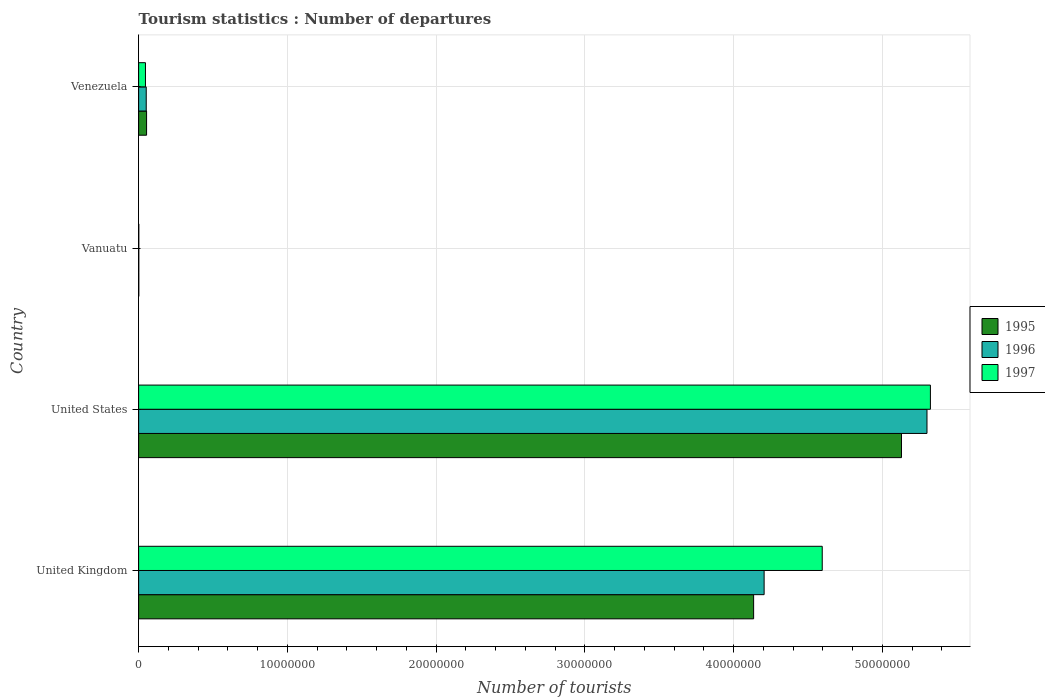How many different coloured bars are there?
Give a very brief answer. 3. How many groups of bars are there?
Offer a terse response. 4. Are the number of bars per tick equal to the number of legend labels?
Provide a short and direct response. Yes. How many bars are there on the 4th tick from the top?
Offer a terse response. 3. What is the label of the 3rd group of bars from the top?
Offer a very short reply. United States. What is the number of tourist departures in 1996 in United Kingdom?
Offer a very short reply. 4.20e+07. Across all countries, what is the maximum number of tourist departures in 1996?
Keep it short and to the point. 5.30e+07. Across all countries, what is the minimum number of tourist departures in 1996?
Provide a short and direct response. 1.10e+04. In which country was the number of tourist departures in 1997 maximum?
Keep it short and to the point. United States. In which country was the number of tourist departures in 1997 minimum?
Provide a short and direct response. Vanuatu. What is the total number of tourist departures in 1997 in the graph?
Give a very brief answer. 9.97e+07. What is the difference between the number of tourist departures in 1995 in United Kingdom and that in Vanuatu?
Keep it short and to the point. 4.13e+07. What is the difference between the number of tourist departures in 1995 in United States and the number of tourist departures in 1996 in Vanuatu?
Offer a very short reply. 5.13e+07. What is the average number of tourist departures in 1995 per country?
Make the answer very short. 2.33e+07. What is the difference between the number of tourist departures in 1996 and number of tourist departures in 1995 in Vanuatu?
Your response must be concise. 0. What is the ratio of the number of tourist departures in 1995 in United States to that in Venezuela?
Make the answer very short. 96.04. Is the difference between the number of tourist departures in 1996 in United Kingdom and Vanuatu greater than the difference between the number of tourist departures in 1995 in United Kingdom and Vanuatu?
Ensure brevity in your answer.  Yes. What is the difference between the highest and the second highest number of tourist departures in 1996?
Offer a terse response. 1.09e+07. What is the difference between the highest and the lowest number of tourist departures in 1996?
Provide a succinct answer. 5.30e+07. Is the sum of the number of tourist departures in 1995 in United States and Venezuela greater than the maximum number of tourist departures in 1996 across all countries?
Provide a succinct answer. No. What does the 3rd bar from the bottom in Vanuatu represents?
Offer a very short reply. 1997. Are all the bars in the graph horizontal?
Your answer should be very brief. Yes. What is the difference between two consecutive major ticks on the X-axis?
Ensure brevity in your answer.  1.00e+07. Are the values on the major ticks of X-axis written in scientific E-notation?
Your answer should be compact. No. Does the graph contain any zero values?
Ensure brevity in your answer.  No. Does the graph contain grids?
Your answer should be very brief. Yes. How many legend labels are there?
Offer a terse response. 3. How are the legend labels stacked?
Provide a succinct answer. Vertical. What is the title of the graph?
Offer a very short reply. Tourism statistics : Number of departures. What is the label or title of the X-axis?
Your answer should be very brief. Number of tourists. What is the label or title of the Y-axis?
Make the answer very short. Country. What is the Number of tourists in 1995 in United Kingdom?
Give a very brief answer. 4.13e+07. What is the Number of tourists of 1996 in United Kingdom?
Ensure brevity in your answer.  4.20e+07. What is the Number of tourists in 1997 in United Kingdom?
Your answer should be very brief. 4.60e+07. What is the Number of tourists of 1995 in United States?
Provide a short and direct response. 5.13e+07. What is the Number of tourists of 1996 in United States?
Your answer should be very brief. 5.30e+07. What is the Number of tourists in 1997 in United States?
Your answer should be very brief. 5.32e+07. What is the Number of tourists of 1995 in Vanuatu?
Your response must be concise. 1.10e+04. What is the Number of tourists in 1996 in Vanuatu?
Provide a short and direct response. 1.10e+04. What is the Number of tourists of 1997 in Vanuatu?
Your answer should be compact. 1.10e+04. What is the Number of tourists of 1995 in Venezuela?
Offer a very short reply. 5.34e+05. What is the Number of tourists in 1996 in Venezuela?
Provide a short and direct response. 5.11e+05. Across all countries, what is the maximum Number of tourists of 1995?
Ensure brevity in your answer.  5.13e+07. Across all countries, what is the maximum Number of tourists of 1996?
Ensure brevity in your answer.  5.30e+07. Across all countries, what is the maximum Number of tourists of 1997?
Make the answer very short. 5.32e+07. Across all countries, what is the minimum Number of tourists in 1995?
Keep it short and to the point. 1.10e+04. Across all countries, what is the minimum Number of tourists in 1996?
Make the answer very short. 1.10e+04. Across all countries, what is the minimum Number of tourists in 1997?
Your response must be concise. 1.10e+04. What is the total Number of tourists in 1995 in the graph?
Provide a succinct answer. 9.32e+07. What is the total Number of tourists in 1996 in the graph?
Offer a terse response. 9.56e+07. What is the total Number of tourists in 1997 in the graph?
Keep it short and to the point. 9.97e+07. What is the difference between the Number of tourists of 1995 in United Kingdom and that in United States?
Your answer should be compact. -9.94e+06. What is the difference between the Number of tourists of 1996 in United Kingdom and that in United States?
Your response must be concise. -1.09e+07. What is the difference between the Number of tourists of 1997 in United Kingdom and that in United States?
Your answer should be very brief. -7.27e+06. What is the difference between the Number of tourists in 1995 in United Kingdom and that in Vanuatu?
Keep it short and to the point. 4.13e+07. What is the difference between the Number of tourists of 1996 in United Kingdom and that in Vanuatu?
Ensure brevity in your answer.  4.20e+07. What is the difference between the Number of tourists of 1997 in United Kingdom and that in Vanuatu?
Offer a very short reply. 4.59e+07. What is the difference between the Number of tourists in 1995 in United Kingdom and that in Venezuela?
Provide a succinct answer. 4.08e+07. What is the difference between the Number of tourists in 1996 in United Kingdom and that in Venezuela?
Offer a terse response. 4.15e+07. What is the difference between the Number of tourists of 1997 in United Kingdom and that in Venezuela?
Provide a succinct answer. 4.55e+07. What is the difference between the Number of tourists of 1995 in United States and that in Vanuatu?
Provide a short and direct response. 5.13e+07. What is the difference between the Number of tourists of 1996 in United States and that in Vanuatu?
Keep it short and to the point. 5.30e+07. What is the difference between the Number of tourists in 1997 in United States and that in Vanuatu?
Make the answer very short. 5.32e+07. What is the difference between the Number of tourists in 1995 in United States and that in Venezuela?
Provide a short and direct response. 5.08e+07. What is the difference between the Number of tourists of 1996 in United States and that in Venezuela?
Offer a very short reply. 5.25e+07. What is the difference between the Number of tourists of 1997 in United States and that in Venezuela?
Make the answer very short. 5.28e+07. What is the difference between the Number of tourists in 1995 in Vanuatu and that in Venezuela?
Your answer should be compact. -5.23e+05. What is the difference between the Number of tourists of 1996 in Vanuatu and that in Venezuela?
Provide a short and direct response. -5.00e+05. What is the difference between the Number of tourists in 1997 in Vanuatu and that in Venezuela?
Offer a very short reply. -4.49e+05. What is the difference between the Number of tourists in 1995 in United Kingdom and the Number of tourists in 1996 in United States?
Ensure brevity in your answer.  -1.17e+07. What is the difference between the Number of tourists of 1995 in United Kingdom and the Number of tourists of 1997 in United States?
Your answer should be very brief. -1.19e+07. What is the difference between the Number of tourists in 1996 in United Kingdom and the Number of tourists in 1997 in United States?
Offer a very short reply. -1.12e+07. What is the difference between the Number of tourists in 1995 in United Kingdom and the Number of tourists in 1996 in Vanuatu?
Make the answer very short. 4.13e+07. What is the difference between the Number of tourists in 1995 in United Kingdom and the Number of tourists in 1997 in Vanuatu?
Provide a succinct answer. 4.13e+07. What is the difference between the Number of tourists in 1996 in United Kingdom and the Number of tourists in 1997 in Vanuatu?
Your answer should be very brief. 4.20e+07. What is the difference between the Number of tourists in 1995 in United Kingdom and the Number of tourists in 1996 in Venezuela?
Offer a very short reply. 4.08e+07. What is the difference between the Number of tourists of 1995 in United Kingdom and the Number of tourists of 1997 in Venezuela?
Offer a very short reply. 4.09e+07. What is the difference between the Number of tourists in 1996 in United Kingdom and the Number of tourists in 1997 in Venezuela?
Your response must be concise. 4.16e+07. What is the difference between the Number of tourists in 1995 in United States and the Number of tourists in 1996 in Vanuatu?
Provide a short and direct response. 5.13e+07. What is the difference between the Number of tourists of 1995 in United States and the Number of tourists of 1997 in Vanuatu?
Provide a succinct answer. 5.13e+07. What is the difference between the Number of tourists of 1996 in United States and the Number of tourists of 1997 in Vanuatu?
Offer a very short reply. 5.30e+07. What is the difference between the Number of tourists of 1995 in United States and the Number of tourists of 1996 in Venezuela?
Provide a succinct answer. 5.08e+07. What is the difference between the Number of tourists of 1995 in United States and the Number of tourists of 1997 in Venezuela?
Keep it short and to the point. 5.08e+07. What is the difference between the Number of tourists of 1996 in United States and the Number of tourists of 1997 in Venezuela?
Your answer should be very brief. 5.25e+07. What is the difference between the Number of tourists in 1995 in Vanuatu and the Number of tourists in 1996 in Venezuela?
Keep it short and to the point. -5.00e+05. What is the difference between the Number of tourists in 1995 in Vanuatu and the Number of tourists in 1997 in Venezuela?
Provide a succinct answer. -4.49e+05. What is the difference between the Number of tourists of 1996 in Vanuatu and the Number of tourists of 1997 in Venezuela?
Offer a terse response. -4.49e+05. What is the average Number of tourists of 1995 per country?
Offer a very short reply. 2.33e+07. What is the average Number of tourists in 1996 per country?
Your answer should be very brief. 2.39e+07. What is the average Number of tourists in 1997 per country?
Your answer should be compact. 2.49e+07. What is the difference between the Number of tourists in 1995 and Number of tourists in 1996 in United Kingdom?
Offer a very short reply. -7.05e+05. What is the difference between the Number of tourists of 1995 and Number of tourists of 1997 in United Kingdom?
Your response must be concise. -4.61e+06. What is the difference between the Number of tourists of 1996 and Number of tourists of 1997 in United Kingdom?
Provide a short and direct response. -3.91e+06. What is the difference between the Number of tourists in 1995 and Number of tourists in 1996 in United States?
Your answer should be very brief. -1.71e+06. What is the difference between the Number of tourists of 1995 and Number of tourists of 1997 in United States?
Provide a succinct answer. -1.94e+06. What is the difference between the Number of tourists of 1995 and Number of tourists of 1996 in Vanuatu?
Ensure brevity in your answer.  0. What is the difference between the Number of tourists in 1995 and Number of tourists in 1997 in Vanuatu?
Make the answer very short. 0. What is the difference between the Number of tourists in 1996 and Number of tourists in 1997 in Vanuatu?
Ensure brevity in your answer.  0. What is the difference between the Number of tourists of 1995 and Number of tourists of 1996 in Venezuela?
Your answer should be compact. 2.30e+04. What is the difference between the Number of tourists in 1995 and Number of tourists in 1997 in Venezuela?
Your answer should be compact. 7.40e+04. What is the difference between the Number of tourists in 1996 and Number of tourists in 1997 in Venezuela?
Offer a very short reply. 5.10e+04. What is the ratio of the Number of tourists of 1995 in United Kingdom to that in United States?
Provide a succinct answer. 0.81. What is the ratio of the Number of tourists in 1996 in United Kingdom to that in United States?
Make the answer very short. 0.79. What is the ratio of the Number of tourists in 1997 in United Kingdom to that in United States?
Provide a succinct answer. 0.86. What is the ratio of the Number of tourists in 1995 in United Kingdom to that in Vanuatu?
Offer a terse response. 3758.64. What is the ratio of the Number of tourists of 1996 in United Kingdom to that in Vanuatu?
Provide a short and direct response. 3822.73. What is the ratio of the Number of tourists of 1997 in United Kingdom to that in Vanuatu?
Offer a terse response. 4177.91. What is the ratio of the Number of tourists of 1995 in United Kingdom to that in Venezuela?
Offer a very short reply. 77.43. What is the ratio of the Number of tourists in 1996 in United Kingdom to that in Venezuela?
Offer a very short reply. 82.29. What is the ratio of the Number of tourists of 1997 in United Kingdom to that in Venezuela?
Provide a short and direct response. 99.91. What is the ratio of the Number of tourists in 1995 in United States to that in Vanuatu?
Keep it short and to the point. 4662.27. What is the ratio of the Number of tourists of 1996 in United States to that in Vanuatu?
Your answer should be compact. 4818.09. What is the ratio of the Number of tourists in 1997 in United States to that in Vanuatu?
Offer a terse response. 4839. What is the ratio of the Number of tourists in 1995 in United States to that in Venezuela?
Provide a short and direct response. 96.04. What is the ratio of the Number of tourists in 1996 in United States to that in Venezuela?
Your answer should be compact. 103.72. What is the ratio of the Number of tourists of 1997 in United States to that in Venezuela?
Ensure brevity in your answer.  115.72. What is the ratio of the Number of tourists in 1995 in Vanuatu to that in Venezuela?
Your answer should be compact. 0.02. What is the ratio of the Number of tourists in 1996 in Vanuatu to that in Venezuela?
Your answer should be compact. 0.02. What is the ratio of the Number of tourists in 1997 in Vanuatu to that in Venezuela?
Make the answer very short. 0.02. What is the difference between the highest and the second highest Number of tourists in 1995?
Make the answer very short. 9.94e+06. What is the difference between the highest and the second highest Number of tourists in 1996?
Keep it short and to the point. 1.09e+07. What is the difference between the highest and the second highest Number of tourists in 1997?
Offer a terse response. 7.27e+06. What is the difference between the highest and the lowest Number of tourists in 1995?
Give a very brief answer. 5.13e+07. What is the difference between the highest and the lowest Number of tourists in 1996?
Your answer should be compact. 5.30e+07. What is the difference between the highest and the lowest Number of tourists in 1997?
Your response must be concise. 5.32e+07. 